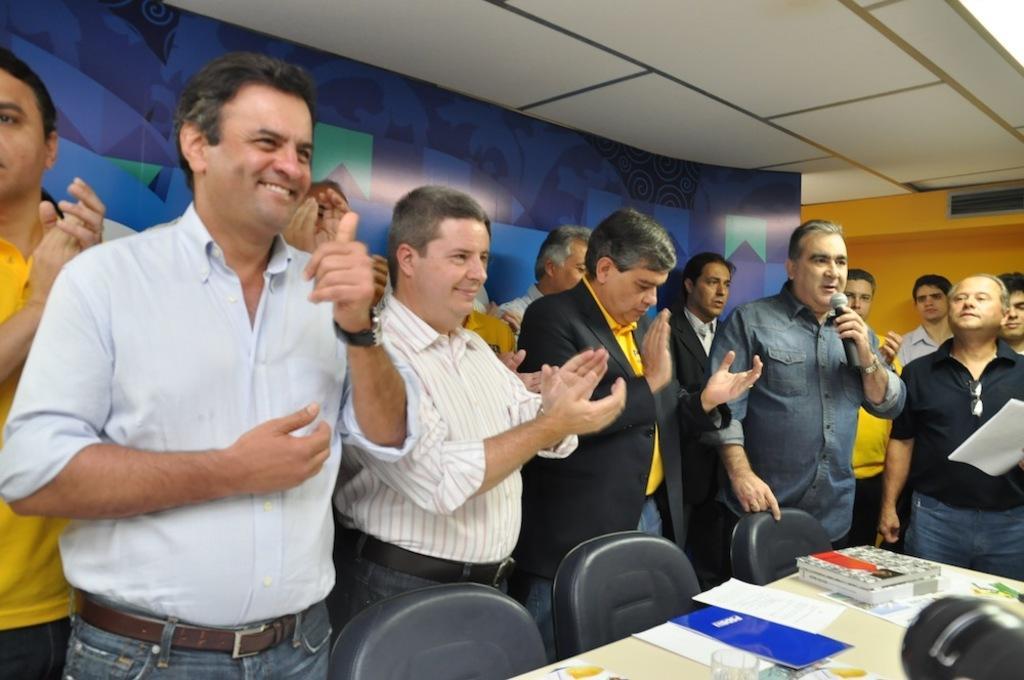Describe this image in one or two sentences. In this picture we can see many people are standing and some of them clapping and on the right side one person holding a paper. 